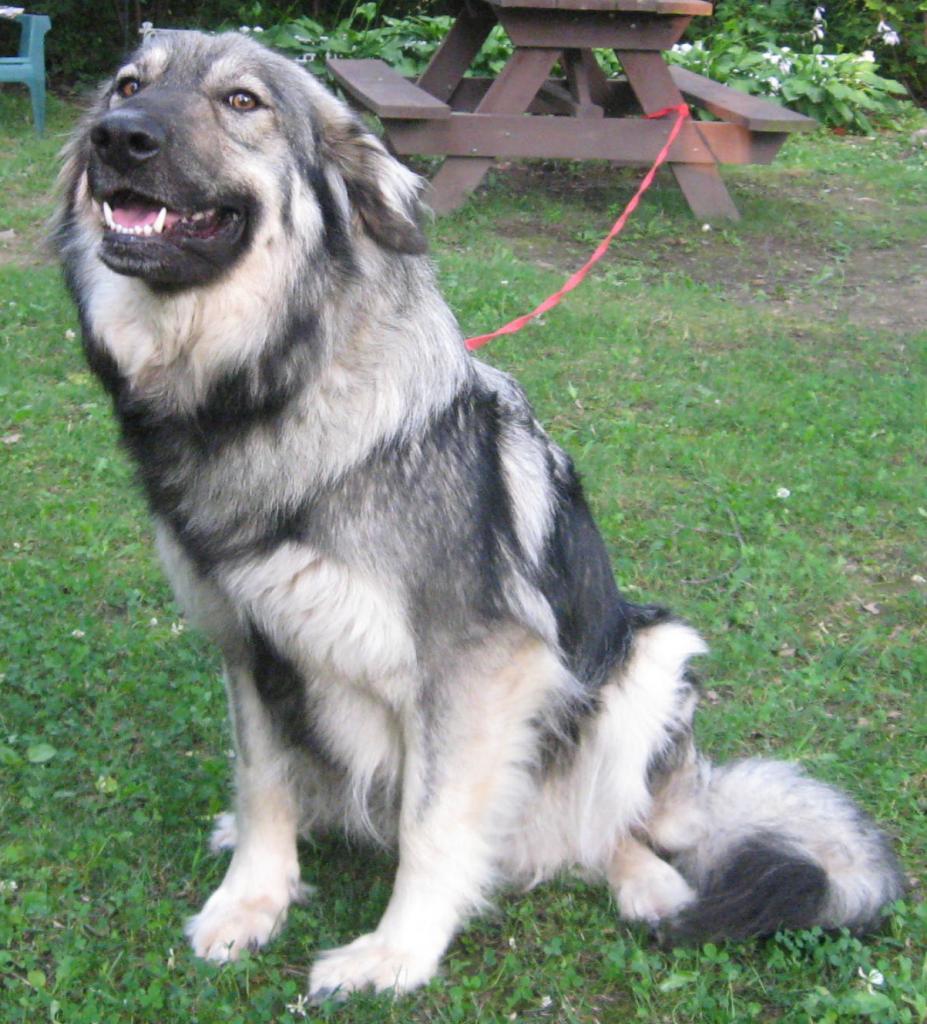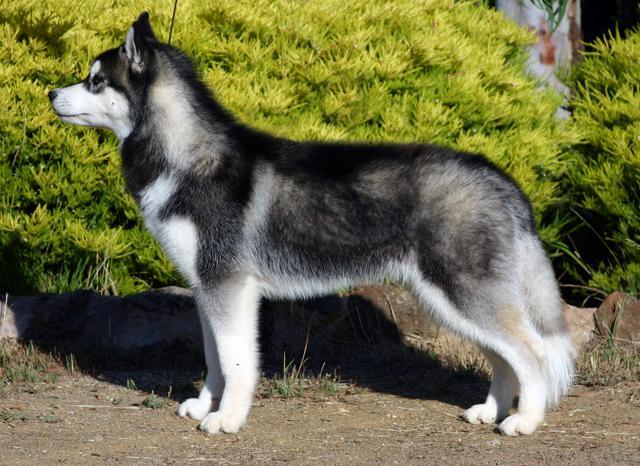The first image is the image on the left, the second image is the image on the right. For the images shown, is this caption "At least one dog is on a leash." true? Answer yes or no. Yes. The first image is the image on the left, the second image is the image on the right. Assess this claim about the two images: "One image shows a dog sitting upright, and the other image features a dog standing on all fours.". Correct or not? Answer yes or no. Yes. 